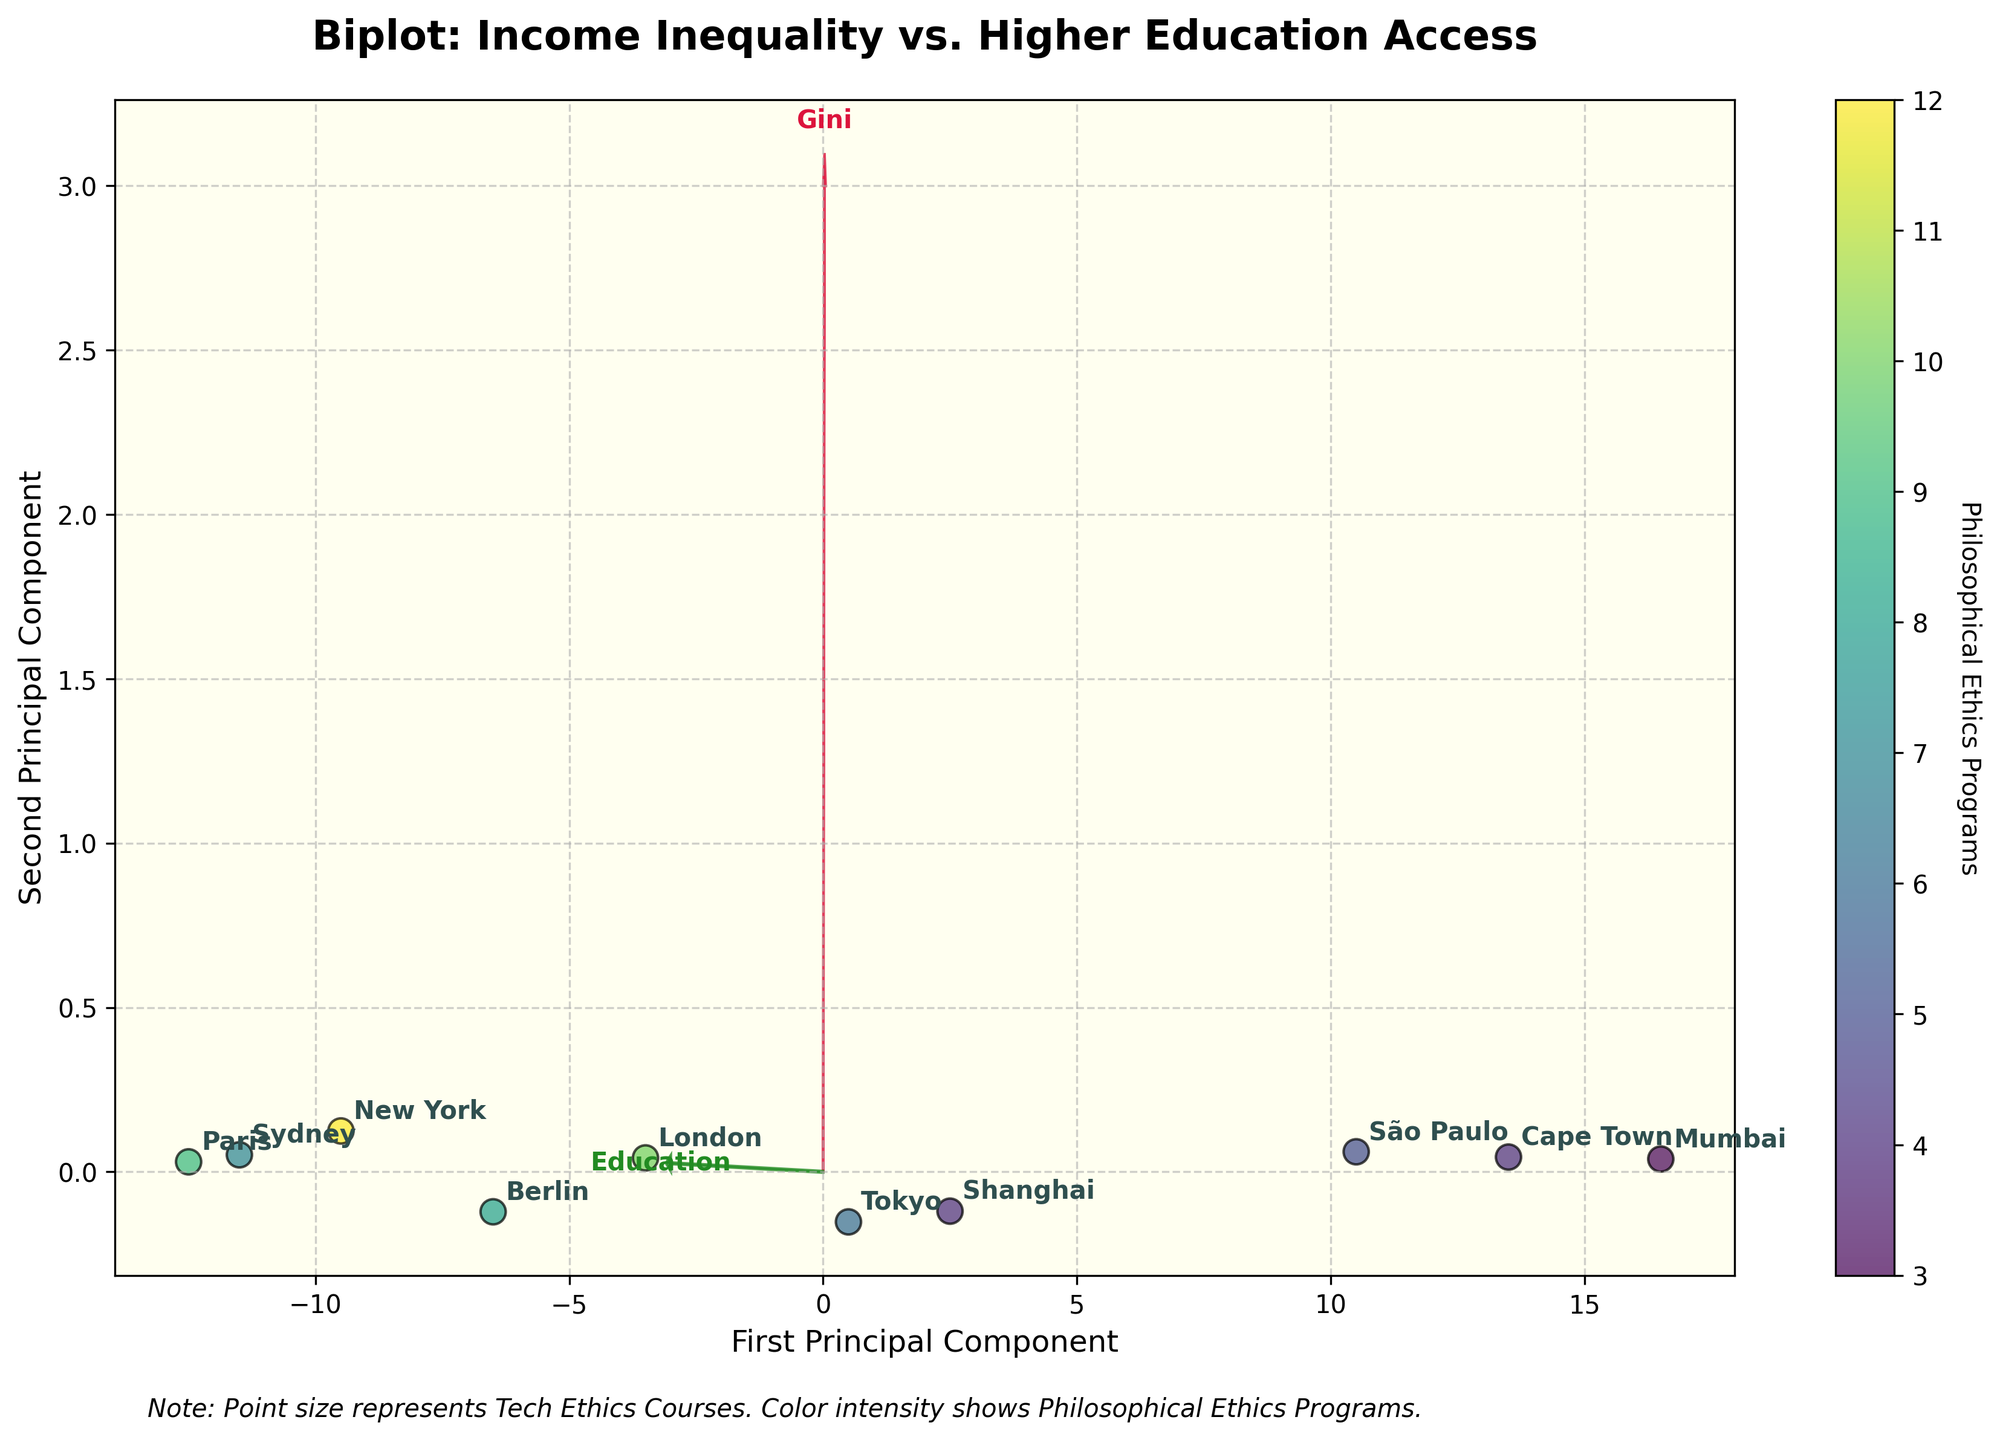What is the title of the figure? The title is written at the top of the figure. It reads, "Biplot: Income Inequality vs. Higher Education Access".
Answer: Biplot: Income Inequality vs. Higher Education Access How many cities are represented in the figure? Count the number of different labels (cities) shown on the plot. Each label represents one city. There are 10 city labels.
Answer: 10 Which city has the highest Higher Education Enrollment Rate? Find the city label that is located furthest in the direction of the “Education” arrow on the biplot. This indicates a higher Higher Education Enrollment Rate. Paris, near the end of the Education arrow, has the highest enrollment rate.
Answer: Paris Which axis corresponds to the first principal component in the biplot? The label for the First Principal Component is on the horizontal (x) axis as indicated by the axis title.
Answer: Horizontal axis How are the number of Philosophical Ethics Programs represented in the figure? The color intensity of the data points represents the number of Philosophical Ethics Programs, as indicated in the figure's colorbar.
Answer: Color intensity What does the size of the points represent? The text explanation below the plot mentions that the point size represents Tech Ethics Courses.
Answer: Tech Ethics Courses How does Tokyo's Higher Education Enrollment Rate compare to Mumbai's? Locate the points for Tokyo and Mumbai. Note their positions relative to the "Education" arrow. Tokyo is closer to the base of the arrow, indicating a higher rate compared to Mumbai.
Answer: Tokyo has a higher rate Which city appears furthest from the origin along the first principal component? Look for the city that is positioned farthest along the horizontal axis, which represents the first principal component. São Paulo is the furthest along this axis.
Answer: São Paulo Which data point is closest to the origin and what does this indicate? Identify the data point nearest the center (0,0). The city near the origin is Shanghai, indicating moderate levels of both variables.
Answer: Shanghai Does New York or London have more Philosophical Ethics Programs? Compare the color intensities of the points for New York and London. New York is more intense, indicating more Philosophical Ethics Programs.
Answer: New York 